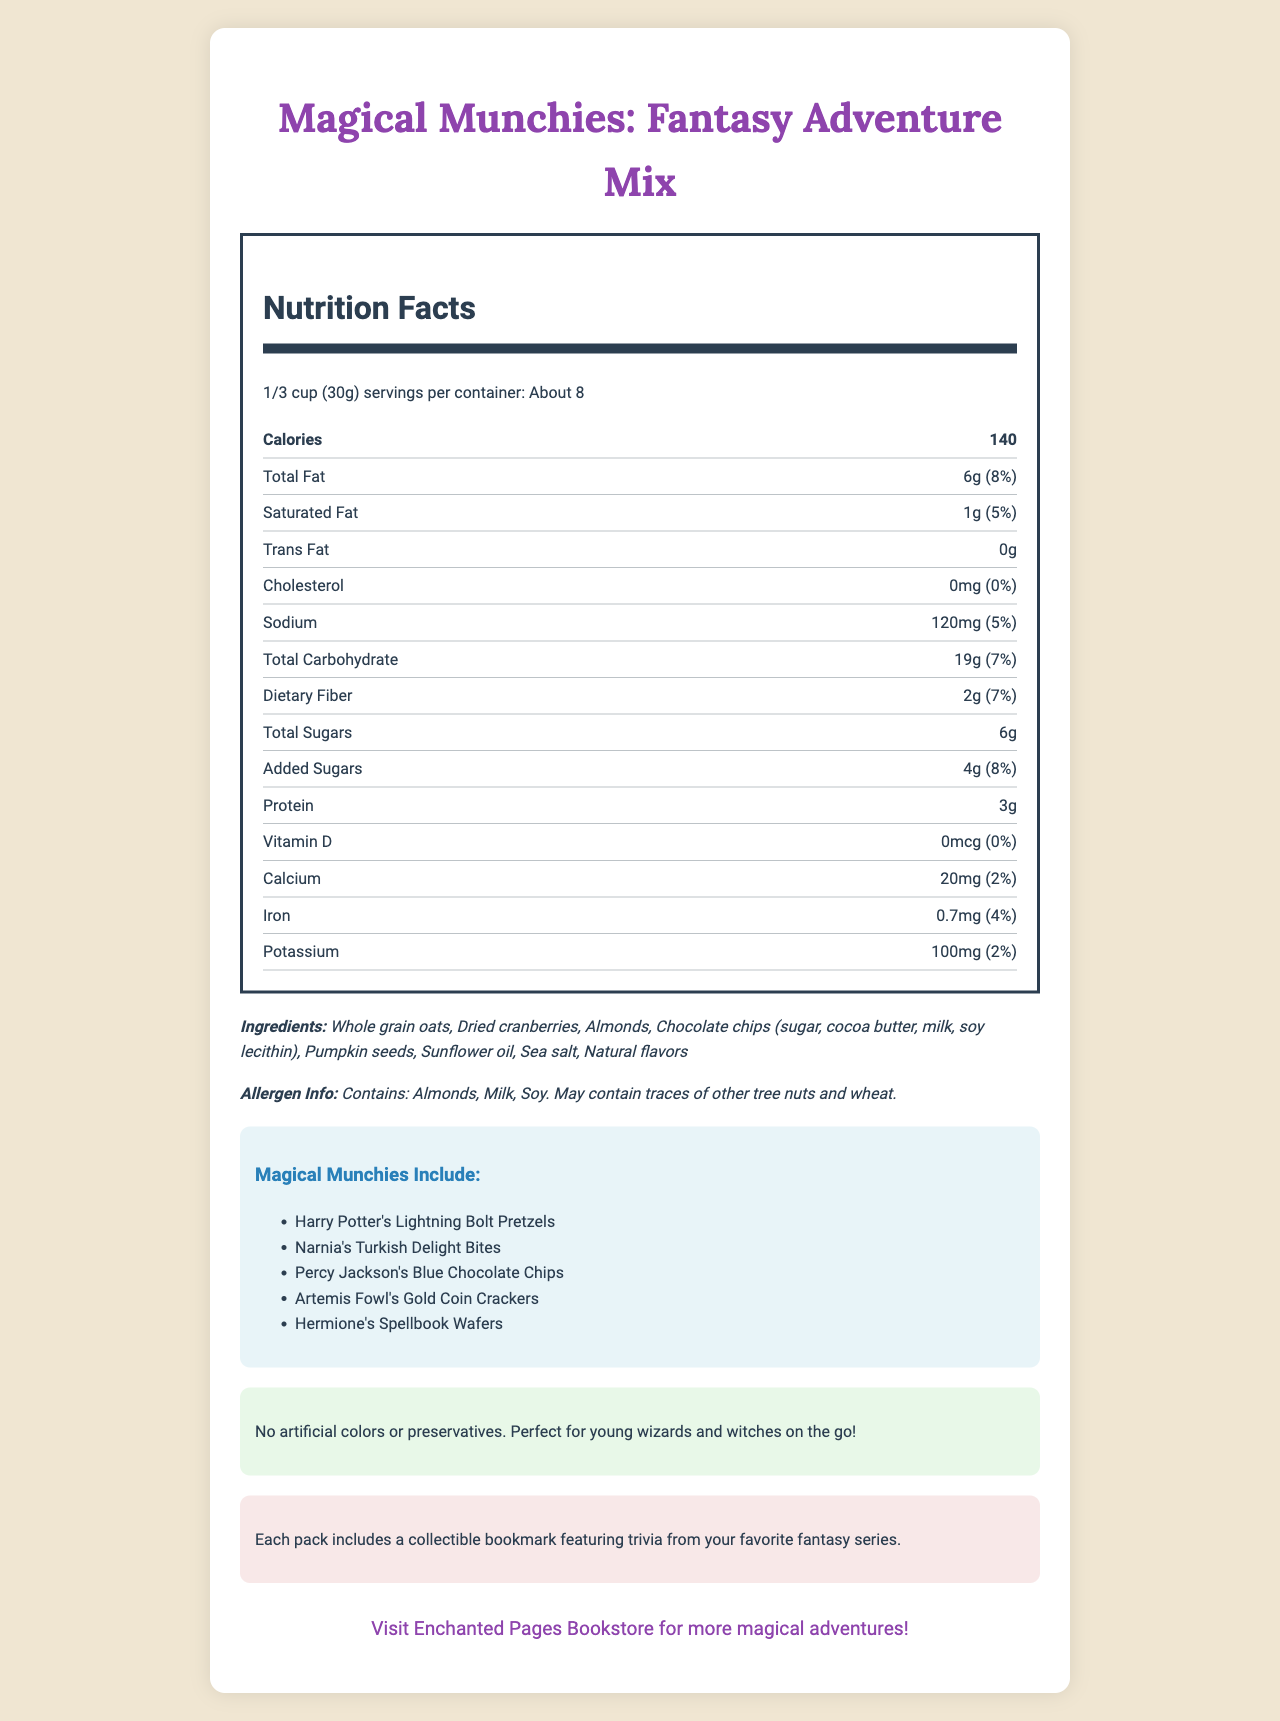what is the serving size of the Magical Munchies? The serving size is explicitly listed as "1/3 cup (30g)" at the top of the nutrition label section.
Answer: 1/3 cup (30g) how many calories are there per serving? The calories per serving are indicated as 140 in the bolded nutrition item section.
Answer: 140 how much total fat is in each serving? The total fat per serving is shown as "6g" with a daily value of 8%.
Answer: 6g what are the main ingredients of the Magical Munchies? The ingredients are listed explicitly in the ingredients section.
Answer: Whole grain oats, Dried cranberries, Almonds, Chocolate chips, Pumpkin seeds, Sunflower oil, Sea salt, Natural flavors which fantasy character-themed snack is NOT included in the Magical Munchies? A. Harry Potter's Lightning Bolt Pretzels B. Narnia's Turkish Delight Bites C. Hobbit's Dragon Scales Chips D. Percy's Blue Chocolate Chips The Hobbit's Dragon Scales Chips are not mentioned in the fantasy characters list.
Answer: C how much protein is in one serving? The amount of protein per serving is listed as "3g" in the nutrition facts section.
Answer: 3g is the snack mix suitable for people with nut allergies? The allergen information states that the snack contains almonds and may contain traces of other tree nuts.
Answer: No what promotional feature does each pack include? The literacy boost section mentions that each pack includes a collectible bookmark.
Answer: A collectible bookmark featuring trivia from favorite fantasy series what is the sodium content per serving in this snack mix? The sodium content per serving is 120mg, as stated in the nutrition facts section.
Answer: 120mg does the snack contain any artificial colors or preservatives? The parent appeal section mentions that the snack mix has no artificial colors or preservatives.
Answer: No which vitamin is completely absent in this snack? A. Vitamin D B. Calcium C. Iron D. Potassium Vitamin D, listed as 0mcg (0%) in the nutrition facts section, is absent.
Answer: A what is the main idea of the document? The document aims to inform buyers about the nutritional makeup, ingredients, unique fantasy-themed elements, and additional features like collectible bookmarks.
Answer: The document provides detailed nutrition facts and ingredient information for "Magical Munchies: Fantasy Adventure Mix", a family-friendly snack mix featuring characters from children's fantasy series, along with promotional and allergen information. are "Harry Potter's Lightning Bolt Pretzels" included in the snack mix? The fantasy characters section specifically lists "Harry Potter's Lightning Bolt Pretzels".
Answer: Yes can we determine the exact price of the Magical Munchies from the document? The document does not provide any pricing information, it focuses on the nutritional and promotional aspects.
Answer: Not enough information 